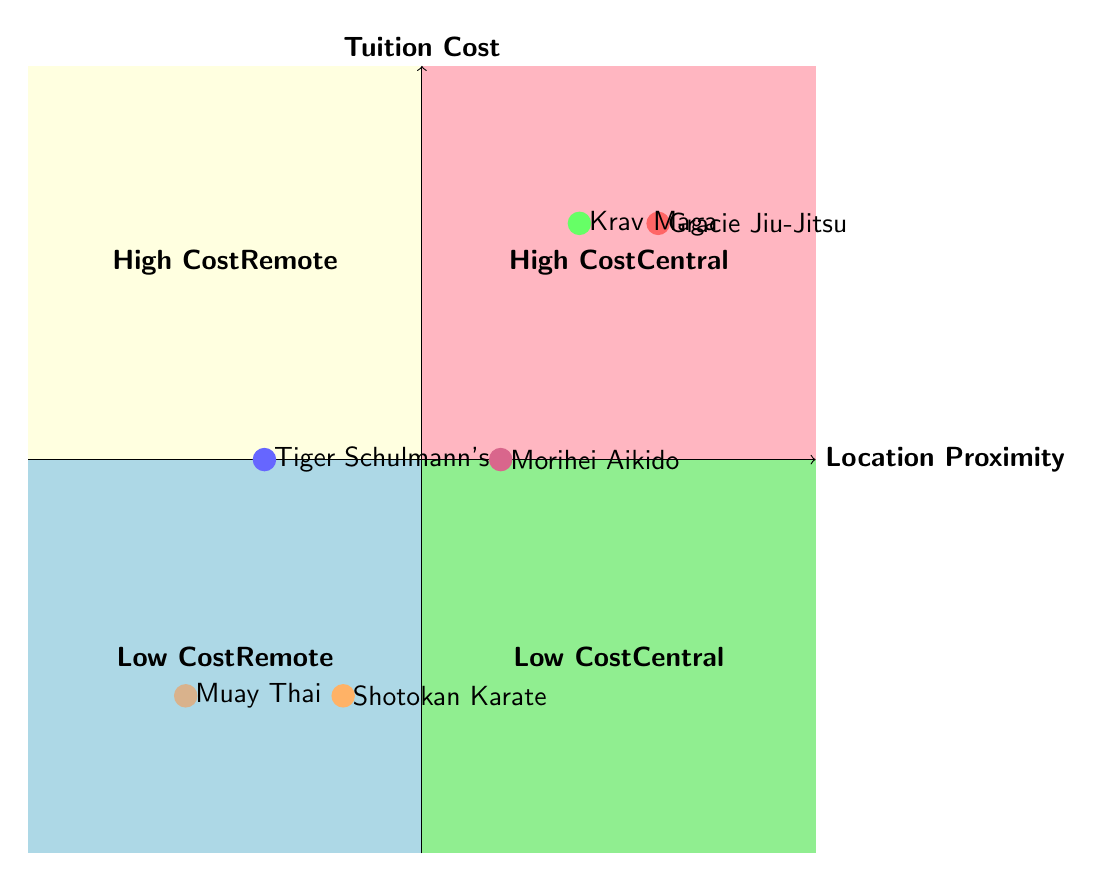What school is in the "High Cost Central" quadrant? In the "High Cost Central" quadrant, the schools listed are positioned based on their location proximity and tuition cost. The only school placed there is Krav Maga Worldwide.
Answer: Krav Maga Worldwide How many schools have a low tuition cost? The "Low Cost Remote" quadrant contains Shotokan Karate Dojo and Muay Thai Training Club, while the "Low Cost Central" quadrant is empty. Counting the schools in the "Low Cost Remote" quadrant gives us a total of two schools.
Answer: 2 What is the location of Tiger Schulmann's Martial Arts? Tiger Schulmann's Martial Arts is positioned in the quadrant defined as "Medium" tuition cost and "Suburbs" proximity. Therefore, its location is the suburbs.
Answer: Suburbs Is there any school in the "Low Cost Central" quadrant? The "Low Cost Central" quadrant is meant for schools with low tuition and central locations. According to the diagram, there are no schools listed in that quadrant.
Answer: No Which school has a high tuition cost and is also located downtown? In the diagram, we check the "High Cost" quadrant, looking for proximity labels. The only school matching both criteria of high tuition cost and downtown location is Gracie Jiu-Jitsu Academy.
Answer: Gracie Jiu-Jitsu Academy What distinguishes "High Cost Remote" from "Low Cost Remote"? The "High Cost Remote" quadrant features schools that are remote in location but charge high tuition, while the "Low Cost Remote" quadrant includes schools that are also remote but charge lower tuition. The difference lies in their tuition costs and location proximity.
Answer: Tuition cost How does the proximity of Morihei Aikido Institute compare to Shotokan Karate Dojo? Morihei Aikido Institute is located near a university implying a central location while Shotokan Karate Dojo is in a residential area, considered remote. Thus, Morihei Aikido is more centrally located compared to Shotokan Karate Dojo.
Answer: More central 